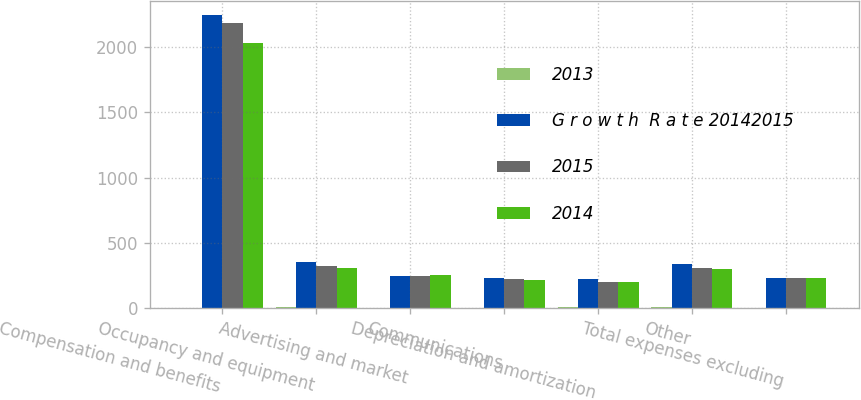<chart> <loc_0><loc_0><loc_500><loc_500><stacked_bar_chart><ecel><fcel>Compensation and benefits<fcel>Occupancy and equipment<fcel>Advertising and market<fcel>Communications<fcel>Depreciation and amortization<fcel>Other<fcel>Total expenses excluding<nl><fcel>2013<fcel>3<fcel>9<fcel>2<fcel>4<fcel>13<fcel>10<fcel>4<nl><fcel>G r o w t h  R a t e 20142015<fcel>2241<fcel>353<fcel>249<fcel>233<fcel>224<fcel>342<fcel>233<nl><fcel>2015<fcel>2184<fcel>324<fcel>245<fcel>223<fcel>199<fcel>311<fcel>233<nl><fcel>2014<fcel>2027<fcel>309<fcel>257<fcel>220<fcel>202<fcel>300<fcel>233<nl></chart> 